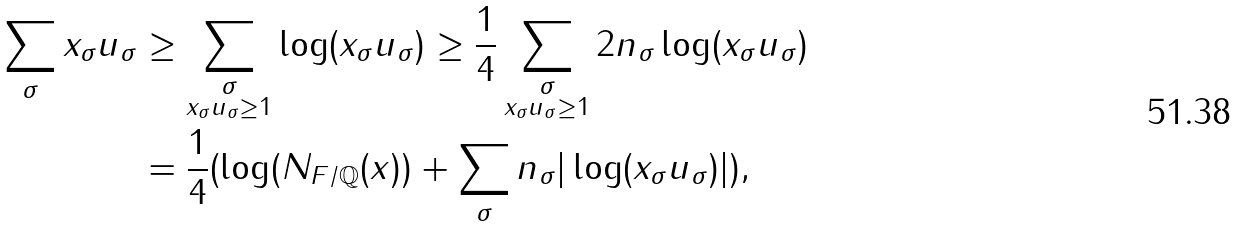Convert formula to latex. <formula><loc_0><loc_0><loc_500><loc_500>\sum _ { \sigma } x _ { \sigma } u _ { \sigma } & \geq \sum _ { \substack { \sigma \\ x _ { \sigma } u _ { \sigma } \geq 1 } } \log ( x _ { \sigma } u _ { \sigma } ) \geq \frac { 1 } { 4 } \sum _ { \substack { \sigma \\ x _ { \sigma } u _ { \sigma } \geq 1 } } 2 n _ { \sigma } \log ( x _ { \sigma } u _ { \sigma } ) \\ & = \frac { 1 } { 4 } ( \log ( N _ { F / \mathbb { Q } } ( x ) ) + \sum _ { \sigma } n _ { \sigma } | \log ( x _ { \sigma } u _ { \sigma } ) | ) ,</formula> 